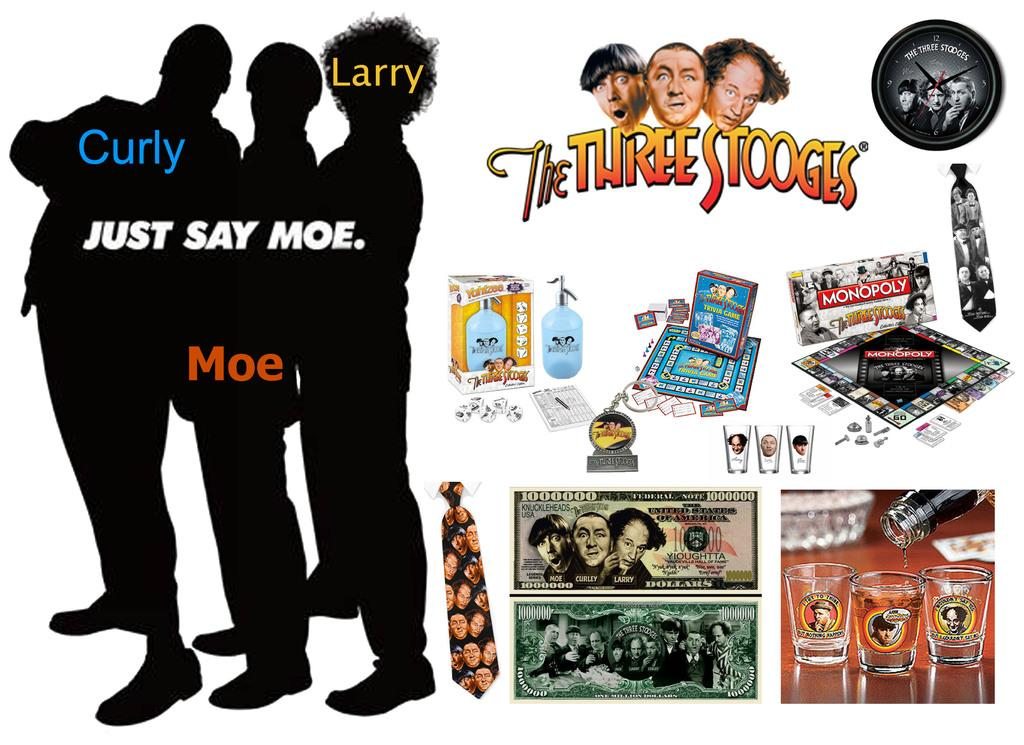Provide a one-sentence caption for the provided image. A Three Stooges Collectibles Memorbillia Display with various souveneirs. 